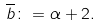<formula> <loc_0><loc_0><loc_500><loc_500>\overline { b } \colon = \alpha + 2 .</formula> 